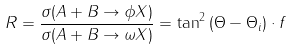<formula> <loc_0><loc_0><loc_500><loc_500>R = \frac { \sigma ( A + B \rightarrow \phi X ) } { \sigma ( A + B \rightarrow \omega X ) } = \tan ^ { 2 } { ( \Theta - \Theta _ { i } ) } \cdot f</formula> 